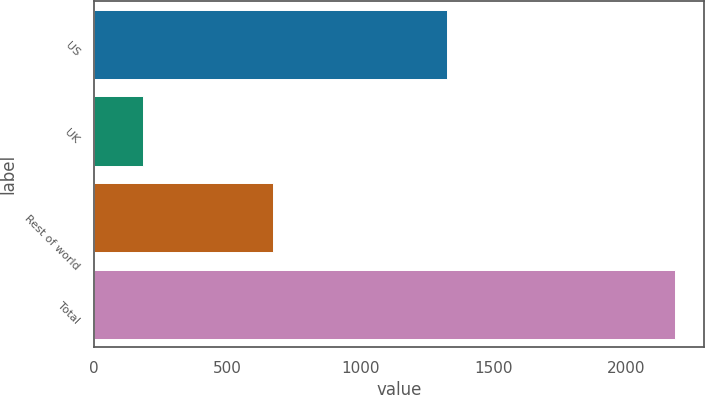<chart> <loc_0><loc_0><loc_500><loc_500><bar_chart><fcel>US<fcel>UK<fcel>Rest of world<fcel>Total<nl><fcel>1327.4<fcel>183.9<fcel>673<fcel>2184.3<nl></chart> 